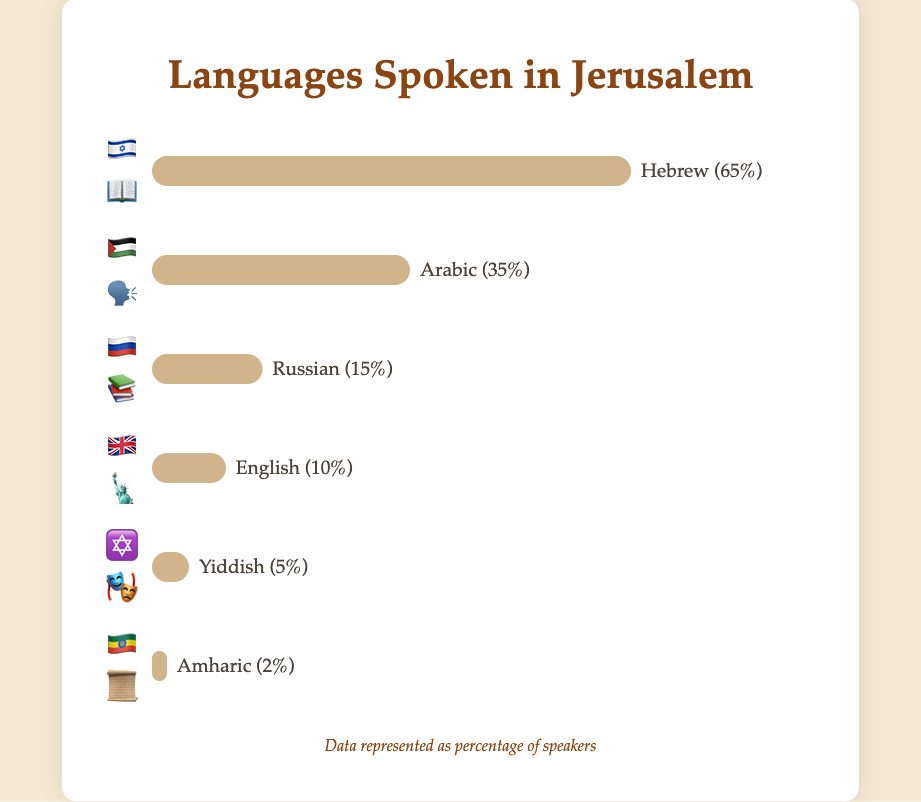What is the title of the chart? The chart title is usually displayed at the top of the chart. It is written in a larger font and summarizes the main topic the chart is representing.
Answer: Languages Spoken in Jerusalem Which language has the most speakers? To determine which language has the most speakers, look for the bar with the greatest width. The label next to this bar indicates the language and the percentage of speakers.
Answer: Hebrew What percentage of residents speak Amharic? Identify the bar labeled "Amharic" and read the percentage next to it. In the chart, this bar is represented by the emoji 🇪🇹📜.
Answer: 2% Compare the number of Hebrew and Arabic speakers. The bar chart shows Hebrew has 65% speakers and Arabic has 35% speakers. Subtract the smaller percentage from the larger one to determine the difference: 65% - 35%.
Answer: 30% How many languages are depicted in the chart? The number of different bars or emojis in the chart corresponds to the number of languages depicted. Count each unique label to find the total number of languages shown.
Answer: 6 What is the sum of the percentages of Russian and English speakers? Find the percentages of Russian speakers (15%) and English speakers (10%). Add these two percentages together: 15% + 10%.
Answer: 25% Which language has the fewest speakers? Look for the bar with the smallest width, which corresponds to the language with the fewest speakers. The label next to this bar will show the language and the percentage.
Answer: Amharic How much more popular is Hebrew compared to Yiddish? Hebrew has 65% speakers and Yiddish has 5% speakers. Subtract the percentage of Yiddish speakers from the percentage of Hebrew speakers to find the difference: 65% - 5%.
Answer: 60% If the percentages are expressed as fractions of 100, what fraction of residents speak languages other than Hebrew and Arabic? Subtract the percentages of Hebrew and Arabic speakers from 100%: 100% - 65% - 35% = 100% - 100% = 0%. Since this includes all residents, the remaining fraction is all those other than Hebrew and Arabic: 1 - 1 = 0.
Answer: 0 